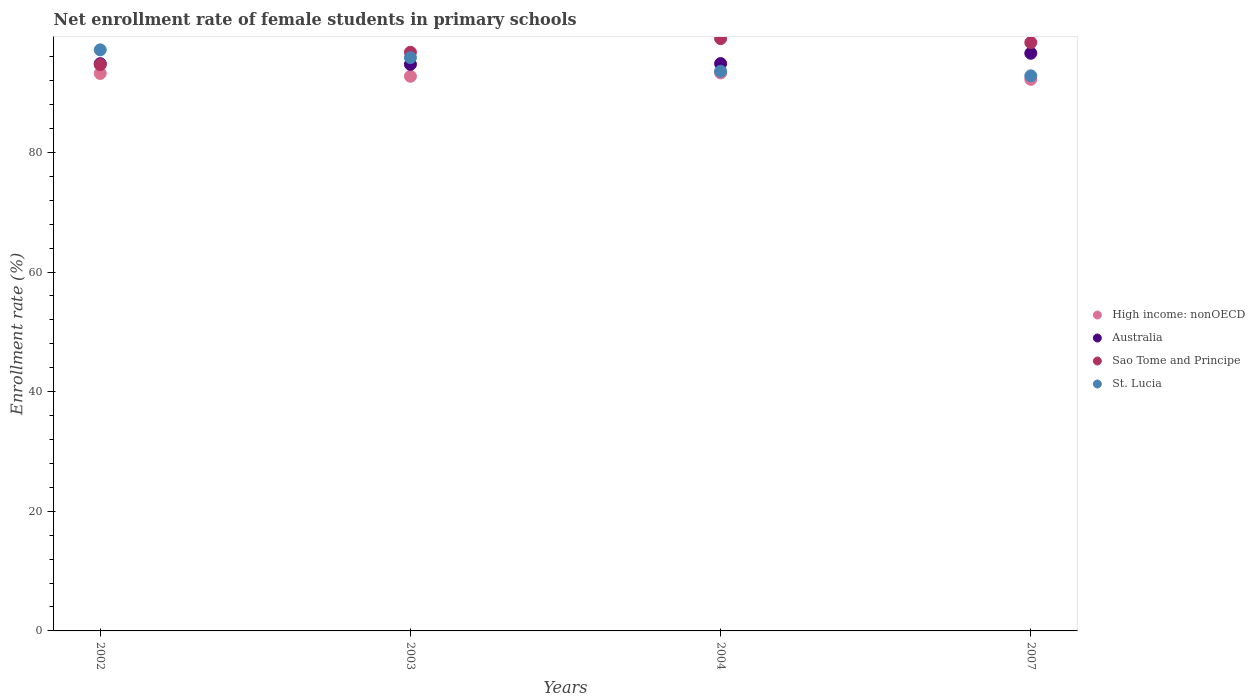Is the number of dotlines equal to the number of legend labels?
Keep it short and to the point. Yes. What is the net enrollment rate of female students in primary schools in Sao Tome and Principe in 2002?
Keep it short and to the point. 94.68. Across all years, what is the maximum net enrollment rate of female students in primary schools in Sao Tome and Principe?
Offer a very short reply. 99.03. Across all years, what is the minimum net enrollment rate of female students in primary schools in Australia?
Keep it short and to the point. 94.73. What is the total net enrollment rate of female students in primary schools in Sao Tome and Principe in the graph?
Offer a very short reply. 388.82. What is the difference between the net enrollment rate of female students in primary schools in Sao Tome and Principe in 2003 and that in 2004?
Make the answer very short. -2.28. What is the difference between the net enrollment rate of female students in primary schools in Sao Tome and Principe in 2004 and the net enrollment rate of female students in primary schools in High income: nonOECD in 2007?
Offer a very short reply. 6.81. What is the average net enrollment rate of female students in primary schools in St. Lucia per year?
Ensure brevity in your answer.  94.84. In the year 2003, what is the difference between the net enrollment rate of female students in primary schools in High income: nonOECD and net enrollment rate of female students in primary schools in Sao Tome and Principe?
Provide a succinct answer. -4.02. What is the ratio of the net enrollment rate of female students in primary schools in Sao Tome and Principe in 2003 to that in 2007?
Your answer should be very brief. 0.98. Is the net enrollment rate of female students in primary schools in Sao Tome and Principe in 2003 less than that in 2004?
Keep it short and to the point. Yes. Is the difference between the net enrollment rate of female students in primary schools in High income: nonOECD in 2002 and 2007 greater than the difference between the net enrollment rate of female students in primary schools in Sao Tome and Principe in 2002 and 2007?
Your answer should be compact. Yes. What is the difference between the highest and the second highest net enrollment rate of female students in primary schools in Australia?
Provide a short and direct response. 1.73. What is the difference between the highest and the lowest net enrollment rate of female students in primary schools in Australia?
Your answer should be compact. 1.86. Is it the case that in every year, the sum of the net enrollment rate of female students in primary schools in Australia and net enrollment rate of female students in primary schools in Sao Tome and Principe  is greater than the sum of net enrollment rate of female students in primary schools in High income: nonOECD and net enrollment rate of female students in primary schools in St. Lucia?
Your answer should be very brief. No. Is it the case that in every year, the sum of the net enrollment rate of female students in primary schools in Australia and net enrollment rate of female students in primary schools in Sao Tome and Principe  is greater than the net enrollment rate of female students in primary schools in High income: nonOECD?
Offer a very short reply. Yes. Does the net enrollment rate of female students in primary schools in Sao Tome and Principe monotonically increase over the years?
Offer a very short reply. No. Is the net enrollment rate of female students in primary schools in High income: nonOECD strictly greater than the net enrollment rate of female students in primary schools in Australia over the years?
Offer a terse response. No. Where does the legend appear in the graph?
Give a very brief answer. Center right. What is the title of the graph?
Make the answer very short. Net enrollment rate of female students in primary schools. Does "Peru" appear as one of the legend labels in the graph?
Provide a succinct answer. No. What is the label or title of the X-axis?
Keep it short and to the point. Years. What is the label or title of the Y-axis?
Provide a short and direct response. Enrollment rate (%). What is the Enrollment rate (%) of High income: nonOECD in 2002?
Offer a terse response. 93.21. What is the Enrollment rate (%) of Australia in 2002?
Offer a terse response. 94.83. What is the Enrollment rate (%) in Sao Tome and Principe in 2002?
Make the answer very short. 94.68. What is the Enrollment rate (%) of St. Lucia in 2002?
Provide a succinct answer. 97.15. What is the Enrollment rate (%) in High income: nonOECD in 2003?
Ensure brevity in your answer.  92.73. What is the Enrollment rate (%) of Australia in 2003?
Make the answer very short. 94.73. What is the Enrollment rate (%) in Sao Tome and Principe in 2003?
Keep it short and to the point. 96.75. What is the Enrollment rate (%) of St. Lucia in 2003?
Make the answer very short. 95.85. What is the Enrollment rate (%) of High income: nonOECD in 2004?
Offer a very short reply. 93.29. What is the Enrollment rate (%) of Australia in 2004?
Keep it short and to the point. 94.85. What is the Enrollment rate (%) in Sao Tome and Principe in 2004?
Your answer should be very brief. 99.03. What is the Enrollment rate (%) of St. Lucia in 2004?
Keep it short and to the point. 93.57. What is the Enrollment rate (%) of High income: nonOECD in 2007?
Your answer should be compact. 92.22. What is the Enrollment rate (%) of Australia in 2007?
Provide a short and direct response. 96.58. What is the Enrollment rate (%) in Sao Tome and Principe in 2007?
Keep it short and to the point. 98.37. What is the Enrollment rate (%) in St. Lucia in 2007?
Make the answer very short. 92.81. Across all years, what is the maximum Enrollment rate (%) of High income: nonOECD?
Give a very brief answer. 93.29. Across all years, what is the maximum Enrollment rate (%) of Australia?
Your response must be concise. 96.58. Across all years, what is the maximum Enrollment rate (%) of Sao Tome and Principe?
Provide a short and direct response. 99.03. Across all years, what is the maximum Enrollment rate (%) in St. Lucia?
Give a very brief answer. 97.15. Across all years, what is the minimum Enrollment rate (%) in High income: nonOECD?
Give a very brief answer. 92.22. Across all years, what is the minimum Enrollment rate (%) in Australia?
Offer a terse response. 94.73. Across all years, what is the minimum Enrollment rate (%) in Sao Tome and Principe?
Keep it short and to the point. 94.68. Across all years, what is the minimum Enrollment rate (%) in St. Lucia?
Give a very brief answer. 92.81. What is the total Enrollment rate (%) of High income: nonOECD in the graph?
Provide a succinct answer. 371.44. What is the total Enrollment rate (%) in Australia in the graph?
Your answer should be very brief. 380.99. What is the total Enrollment rate (%) in Sao Tome and Principe in the graph?
Provide a succinct answer. 388.82. What is the total Enrollment rate (%) of St. Lucia in the graph?
Provide a short and direct response. 379.38. What is the difference between the Enrollment rate (%) in High income: nonOECD in 2002 and that in 2003?
Your answer should be compact. 0.48. What is the difference between the Enrollment rate (%) of Australia in 2002 and that in 2003?
Ensure brevity in your answer.  0.11. What is the difference between the Enrollment rate (%) in Sao Tome and Principe in 2002 and that in 2003?
Keep it short and to the point. -2.07. What is the difference between the Enrollment rate (%) in St. Lucia in 2002 and that in 2003?
Offer a terse response. 1.3. What is the difference between the Enrollment rate (%) in High income: nonOECD in 2002 and that in 2004?
Your answer should be very brief. -0.08. What is the difference between the Enrollment rate (%) of Australia in 2002 and that in 2004?
Provide a short and direct response. -0.02. What is the difference between the Enrollment rate (%) of Sao Tome and Principe in 2002 and that in 2004?
Provide a short and direct response. -4.35. What is the difference between the Enrollment rate (%) of St. Lucia in 2002 and that in 2004?
Make the answer very short. 3.58. What is the difference between the Enrollment rate (%) in Australia in 2002 and that in 2007?
Your answer should be very brief. -1.75. What is the difference between the Enrollment rate (%) in Sao Tome and Principe in 2002 and that in 2007?
Give a very brief answer. -3.69. What is the difference between the Enrollment rate (%) of St. Lucia in 2002 and that in 2007?
Your response must be concise. 4.34. What is the difference between the Enrollment rate (%) in High income: nonOECD in 2003 and that in 2004?
Make the answer very short. -0.56. What is the difference between the Enrollment rate (%) of Australia in 2003 and that in 2004?
Provide a short and direct response. -0.13. What is the difference between the Enrollment rate (%) of Sao Tome and Principe in 2003 and that in 2004?
Offer a very short reply. -2.28. What is the difference between the Enrollment rate (%) of St. Lucia in 2003 and that in 2004?
Ensure brevity in your answer.  2.28. What is the difference between the Enrollment rate (%) in High income: nonOECD in 2003 and that in 2007?
Give a very brief answer. 0.51. What is the difference between the Enrollment rate (%) in Australia in 2003 and that in 2007?
Your answer should be very brief. -1.86. What is the difference between the Enrollment rate (%) of Sao Tome and Principe in 2003 and that in 2007?
Your response must be concise. -1.62. What is the difference between the Enrollment rate (%) in St. Lucia in 2003 and that in 2007?
Provide a short and direct response. 3.04. What is the difference between the Enrollment rate (%) in High income: nonOECD in 2004 and that in 2007?
Ensure brevity in your answer.  1.07. What is the difference between the Enrollment rate (%) in Australia in 2004 and that in 2007?
Provide a short and direct response. -1.73. What is the difference between the Enrollment rate (%) in Sao Tome and Principe in 2004 and that in 2007?
Provide a succinct answer. 0.66. What is the difference between the Enrollment rate (%) of St. Lucia in 2004 and that in 2007?
Give a very brief answer. 0.76. What is the difference between the Enrollment rate (%) in High income: nonOECD in 2002 and the Enrollment rate (%) in Australia in 2003?
Provide a short and direct response. -1.52. What is the difference between the Enrollment rate (%) of High income: nonOECD in 2002 and the Enrollment rate (%) of Sao Tome and Principe in 2003?
Offer a very short reply. -3.54. What is the difference between the Enrollment rate (%) of High income: nonOECD in 2002 and the Enrollment rate (%) of St. Lucia in 2003?
Your answer should be compact. -2.64. What is the difference between the Enrollment rate (%) in Australia in 2002 and the Enrollment rate (%) in Sao Tome and Principe in 2003?
Your answer should be compact. -1.91. What is the difference between the Enrollment rate (%) in Australia in 2002 and the Enrollment rate (%) in St. Lucia in 2003?
Offer a very short reply. -1.01. What is the difference between the Enrollment rate (%) in Sao Tome and Principe in 2002 and the Enrollment rate (%) in St. Lucia in 2003?
Give a very brief answer. -1.17. What is the difference between the Enrollment rate (%) in High income: nonOECD in 2002 and the Enrollment rate (%) in Australia in 2004?
Your response must be concise. -1.64. What is the difference between the Enrollment rate (%) in High income: nonOECD in 2002 and the Enrollment rate (%) in Sao Tome and Principe in 2004?
Make the answer very short. -5.82. What is the difference between the Enrollment rate (%) in High income: nonOECD in 2002 and the Enrollment rate (%) in St. Lucia in 2004?
Your answer should be compact. -0.36. What is the difference between the Enrollment rate (%) of Australia in 2002 and the Enrollment rate (%) of Sao Tome and Principe in 2004?
Keep it short and to the point. -4.19. What is the difference between the Enrollment rate (%) in Australia in 2002 and the Enrollment rate (%) in St. Lucia in 2004?
Your response must be concise. 1.26. What is the difference between the Enrollment rate (%) in Sao Tome and Principe in 2002 and the Enrollment rate (%) in St. Lucia in 2004?
Your answer should be very brief. 1.11. What is the difference between the Enrollment rate (%) of High income: nonOECD in 2002 and the Enrollment rate (%) of Australia in 2007?
Offer a terse response. -3.37. What is the difference between the Enrollment rate (%) in High income: nonOECD in 2002 and the Enrollment rate (%) in Sao Tome and Principe in 2007?
Ensure brevity in your answer.  -5.16. What is the difference between the Enrollment rate (%) in High income: nonOECD in 2002 and the Enrollment rate (%) in St. Lucia in 2007?
Offer a terse response. 0.4. What is the difference between the Enrollment rate (%) in Australia in 2002 and the Enrollment rate (%) in Sao Tome and Principe in 2007?
Your answer should be compact. -3.54. What is the difference between the Enrollment rate (%) of Australia in 2002 and the Enrollment rate (%) of St. Lucia in 2007?
Give a very brief answer. 2.03. What is the difference between the Enrollment rate (%) of Sao Tome and Principe in 2002 and the Enrollment rate (%) of St. Lucia in 2007?
Your answer should be compact. 1.87. What is the difference between the Enrollment rate (%) of High income: nonOECD in 2003 and the Enrollment rate (%) of Australia in 2004?
Offer a terse response. -2.13. What is the difference between the Enrollment rate (%) in High income: nonOECD in 2003 and the Enrollment rate (%) in Sao Tome and Principe in 2004?
Your answer should be compact. -6.3. What is the difference between the Enrollment rate (%) in High income: nonOECD in 2003 and the Enrollment rate (%) in St. Lucia in 2004?
Your response must be concise. -0.85. What is the difference between the Enrollment rate (%) of Australia in 2003 and the Enrollment rate (%) of Sao Tome and Principe in 2004?
Offer a terse response. -4.3. What is the difference between the Enrollment rate (%) in Australia in 2003 and the Enrollment rate (%) in St. Lucia in 2004?
Ensure brevity in your answer.  1.15. What is the difference between the Enrollment rate (%) of Sao Tome and Principe in 2003 and the Enrollment rate (%) of St. Lucia in 2004?
Offer a very short reply. 3.17. What is the difference between the Enrollment rate (%) in High income: nonOECD in 2003 and the Enrollment rate (%) in Australia in 2007?
Keep it short and to the point. -3.85. What is the difference between the Enrollment rate (%) of High income: nonOECD in 2003 and the Enrollment rate (%) of Sao Tome and Principe in 2007?
Keep it short and to the point. -5.64. What is the difference between the Enrollment rate (%) in High income: nonOECD in 2003 and the Enrollment rate (%) in St. Lucia in 2007?
Offer a very short reply. -0.08. What is the difference between the Enrollment rate (%) of Australia in 2003 and the Enrollment rate (%) of Sao Tome and Principe in 2007?
Your response must be concise. -3.64. What is the difference between the Enrollment rate (%) of Australia in 2003 and the Enrollment rate (%) of St. Lucia in 2007?
Your answer should be very brief. 1.92. What is the difference between the Enrollment rate (%) in Sao Tome and Principe in 2003 and the Enrollment rate (%) in St. Lucia in 2007?
Provide a succinct answer. 3.94. What is the difference between the Enrollment rate (%) in High income: nonOECD in 2004 and the Enrollment rate (%) in Australia in 2007?
Keep it short and to the point. -3.29. What is the difference between the Enrollment rate (%) of High income: nonOECD in 2004 and the Enrollment rate (%) of Sao Tome and Principe in 2007?
Ensure brevity in your answer.  -5.08. What is the difference between the Enrollment rate (%) of High income: nonOECD in 2004 and the Enrollment rate (%) of St. Lucia in 2007?
Ensure brevity in your answer.  0.48. What is the difference between the Enrollment rate (%) in Australia in 2004 and the Enrollment rate (%) in Sao Tome and Principe in 2007?
Your answer should be compact. -3.52. What is the difference between the Enrollment rate (%) in Australia in 2004 and the Enrollment rate (%) in St. Lucia in 2007?
Your answer should be compact. 2.05. What is the difference between the Enrollment rate (%) in Sao Tome and Principe in 2004 and the Enrollment rate (%) in St. Lucia in 2007?
Offer a terse response. 6.22. What is the average Enrollment rate (%) in High income: nonOECD per year?
Your answer should be very brief. 92.86. What is the average Enrollment rate (%) in Australia per year?
Make the answer very short. 95.25. What is the average Enrollment rate (%) of Sao Tome and Principe per year?
Give a very brief answer. 97.21. What is the average Enrollment rate (%) of St. Lucia per year?
Keep it short and to the point. 94.84. In the year 2002, what is the difference between the Enrollment rate (%) of High income: nonOECD and Enrollment rate (%) of Australia?
Provide a short and direct response. -1.63. In the year 2002, what is the difference between the Enrollment rate (%) of High income: nonOECD and Enrollment rate (%) of Sao Tome and Principe?
Provide a short and direct response. -1.47. In the year 2002, what is the difference between the Enrollment rate (%) of High income: nonOECD and Enrollment rate (%) of St. Lucia?
Your answer should be compact. -3.94. In the year 2002, what is the difference between the Enrollment rate (%) in Australia and Enrollment rate (%) in Sao Tome and Principe?
Keep it short and to the point. 0.15. In the year 2002, what is the difference between the Enrollment rate (%) of Australia and Enrollment rate (%) of St. Lucia?
Your answer should be very brief. -2.32. In the year 2002, what is the difference between the Enrollment rate (%) of Sao Tome and Principe and Enrollment rate (%) of St. Lucia?
Ensure brevity in your answer.  -2.47. In the year 2003, what is the difference between the Enrollment rate (%) of High income: nonOECD and Enrollment rate (%) of Australia?
Give a very brief answer. -2. In the year 2003, what is the difference between the Enrollment rate (%) in High income: nonOECD and Enrollment rate (%) in Sao Tome and Principe?
Your answer should be compact. -4.02. In the year 2003, what is the difference between the Enrollment rate (%) in High income: nonOECD and Enrollment rate (%) in St. Lucia?
Your answer should be very brief. -3.12. In the year 2003, what is the difference between the Enrollment rate (%) of Australia and Enrollment rate (%) of Sao Tome and Principe?
Make the answer very short. -2.02. In the year 2003, what is the difference between the Enrollment rate (%) of Australia and Enrollment rate (%) of St. Lucia?
Your answer should be compact. -1.12. In the year 2003, what is the difference between the Enrollment rate (%) of Sao Tome and Principe and Enrollment rate (%) of St. Lucia?
Your response must be concise. 0.9. In the year 2004, what is the difference between the Enrollment rate (%) of High income: nonOECD and Enrollment rate (%) of Australia?
Give a very brief answer. -1.56. In the year 2004, what is the difference between the Enrollment rate (%) of High income: nonOECD and Enrollment rate (%) of Sao Tome and Principe?
Your response must be concise. -5.74. In the year 2004, what is the difference between the Enrollment rate (%) in High income: nonOECD and Enrollment rate (%) in St. Lucia?
Make the answer very short. -0.28. In the year 2004, what is the difference between the Enrollment rate (%) of Australia and Enrollment rate (%) of Sao Tome and Principe?
Ensure brevity in your answer.  -4.18. In the year 2004, what is the difference between the Enrollment rate (%) in Australia and Enrollment rate (%) in St. Lucia?
Provide a short and direct response. 1.28. In the year 2004, what is the difference between the Enrollment rate (%) in Sao Tome and Principe and Enrollment rate (%) in St. Lucia?
Make the answer very short. 5.46. In the year 2007, what is the difference between the Enrollment rate (%) of High income: nonOECD and Enrollment rate (%) of Australia?
Ensure brevity in your answer.  -4.36. In the year 2007, what is the difference between the Enrollment rate (%) in High income: nonOECD and Enrollment rate (%) in Sao Tome and Principe?
Offer a terse response. -6.15. In the year 2007, what is the difference between the Enrollment rate (%) in High income: nonOECD and Enrollment rate (%) in St. Lucia?
Provide a short and direct response. -0.59. In the year 2007, what is the difference between the Enrollment rate (%) in Australia and Enrollment rate (%) in Sao Tome and Principe?
Provide a short and direct response. -1.79. In the year 2007, what is the difference between the Enrollment rate (%) of Australia and Enrollment rate (%) of St. Lucia?
Your answer should be very brief. 3.77. In the year 2007, what is the difference between the Enrollment rate (%) in Sao Tome and Principe and Enrollment rate (%) in St. Lucia?
Your answer should be very brief. 5.56. What is the ratio of the Enrollment rate (%) in Australia in 2002 to that in 2003?
Offer a terse response. 1. What is the ratio of the Enrollment rate (%) in Sao Tome and Principe in 2002 to that in 2003?
Keep it short and to the point. 0.98. What is the ratio of the Enrollment rate (%) in St. Lucia in 2002 to that in 2003?
Ensure brevity in your answer.  1.01. What is the ratio of the Enrollment rate (%) of Australia in 2002 to that in 2004?
Your answer should be very brief. 1. What is the ratio of the Enrollment rate (%) of Sao Tome and Principe in 2002 to that in 2004?
Your answer should be compact. 0.96. What is the ratio of the Enrollment rate (%) of St. Lucia in 2002 to that in 2004?
Provide a succinct answer. 1.04. What is the ratio of the Enrollment rate (%) in High income: nonOECD in 2002 to that in 2007?
Your response must be concise. 1.01. What is the ratio of the Enrollment rate (%) of Australia in 2002 to that in 2007?
Offer a very short reply. 0.98. What is the ratio of the Enrollment rate (%) in Sao Tome and Principe in 2002 to that in 2007?
Provide a succinct answer. 0.96. What is the ratio of the Enrollment rate (%) of St. Lucia in 2002 to that in 2007?
Offer a very short reply. 1.05. What is the ratio of the Enrollment rate (%) in High income: nonOECD in 2003 to that in 2004?
Your answer should be compact. 0.99. What is the ratio of the Enrollment rate (%) of Sao Tome and Principe in 2003 to that in 2004?
Offer a terse response. 0.98. What is the ratio of the Enrollment rate (%) of St. Lucia in 2003 to that in 2004?
Keep it short and to the point. 1.02. What is the ratio of the Enrollment rate (%) in High income: nonOECD in 2003 to that in 2007?
Your response must be concise. 1.01. What is the ratio of the Enrollment rate (%) of Australia in 2003 to that in 2007?
Make the answer very short. 0.98. What is the ratio of the Enrollment rate (%) of Sao Tome and Principe in 2003 to that in 2007?
Ensure brevity in your answer.  0.98. What is the ratio of the Enrollment rate (%) in St. Lucia in 2003 to that in 2007?
Offer a terse response. 1.03. What is the ratio of the Enrollment rate (%) in High income: nonOECD in 2004 to that in 2007?
Offer a terse response. 1.01. What is the ratio of the Enrollment rate (%) in Australia in 2004 to that in 2007?
Provide a short and direct response. 0.98. What is the ratio of the Enrollment rate (%) of St. Lucia in 2004 to that in 2007?
Your answer should be compact. 1.01. What is the difference between the highest and the second highest Enrollment rate (%) in High income: nonOECD?
Your response must be concise. 0.08. What is the difference between the highest and the second highest Enrollment rate (%) in Australia?
Provide a succinct answer. 1.73. What is the difference between the highest and the second highest Enrollment rate (%) of Sao Tome and Principe?
Ensure brevity in your answer.  0.66. What is the difference between the highest and the second highest Enrollment rate (%) of St. Lucia?
Give a very brief answer. 1.3. What is the difference between the highest and the lowest Enrollment rate (%) in High income: nonOECD?
Your response must be concise. 1.07. What is the difference between the highest and the lowest Enrollment rate (%) in Australia?
Make the answer very short. 1.86. What is the difference between the highest and the lowest Enrollment rate (%) in Sao Tome and Principe?
Give a very brief answer. 4.35. What is the difference between the highest and the lowest Enrollment rate (%) of St. Lucia?
Keep it short and to the point. 4.34. 